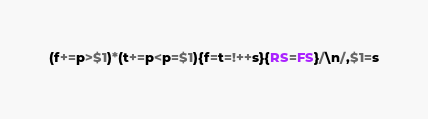<code> <loc_0><loc_0><loc_500><loc_500><_Awk_>(f+=p>$1)*(t+=p<p=$1){f=t=!++s}{RS=FS}/\n/,$1=s</code> 